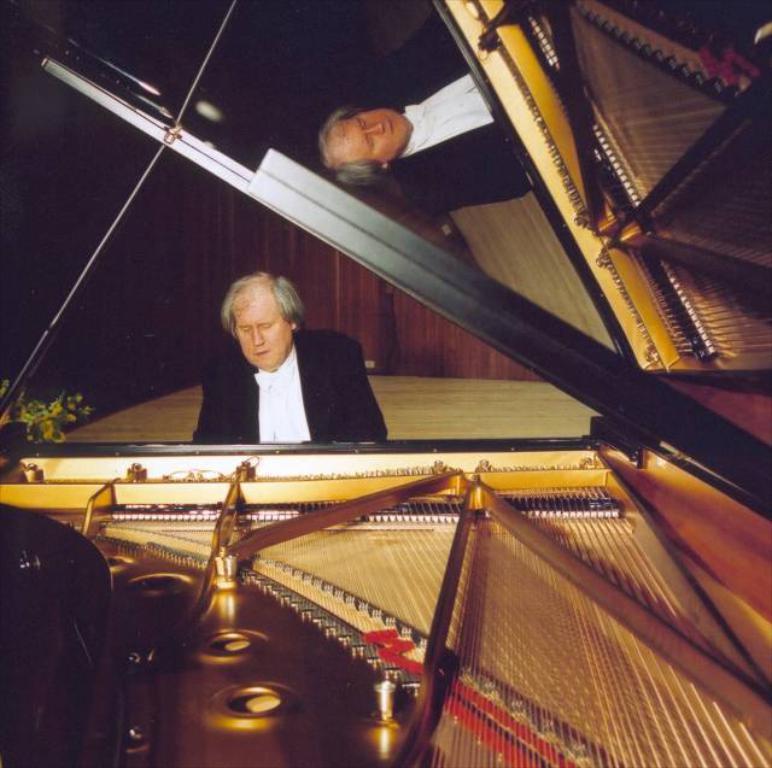How would you summarize this image in a sentence or two? A man is playing a piano. 